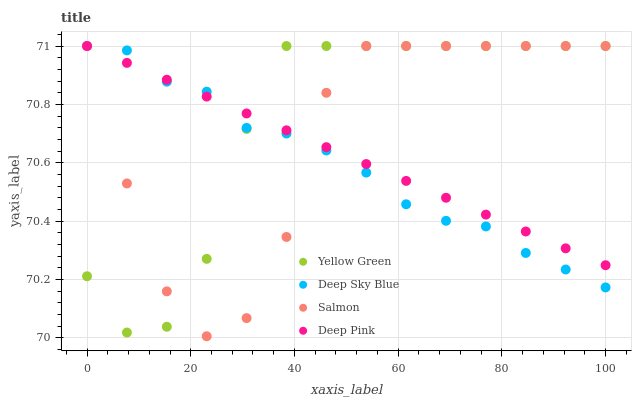Does Deep Sky Blue have the minimum area under the curve?
Answer yes or no. Yes. Does Yellow Green have the maximum area under the curve?
Answer yes or no. Yes. Does Salmon have the minimum area under the curve?
Answer yes or no. No. Does Salmon have the maximum area under the curve?
Answer yes or no. No. Is Deep Pink the smoothest?
Answer yes or no. Yes. Is Salmon the roughest?
Answer yes or no. Yes. Is Yellow Green the smoothest?
Answer yes or no. No. Is Yellow Green the roughest?
Answer yes or no. No. Does Salmon have the lowest value?
Answer yes or no. Yes. Does Yellow Green have the lowest value?
Answer yes or no. No. Does Deep Sky Blue have the highest value?
Answer yes or no. Yes. Does Salmon intersect Deep Pink?
Answer yes or no. Yes. Is Salmon less than Deep Pink?
Answer yes or no. No. Is Salmon greater than Deep Pink?
Answer yes or no. No. 